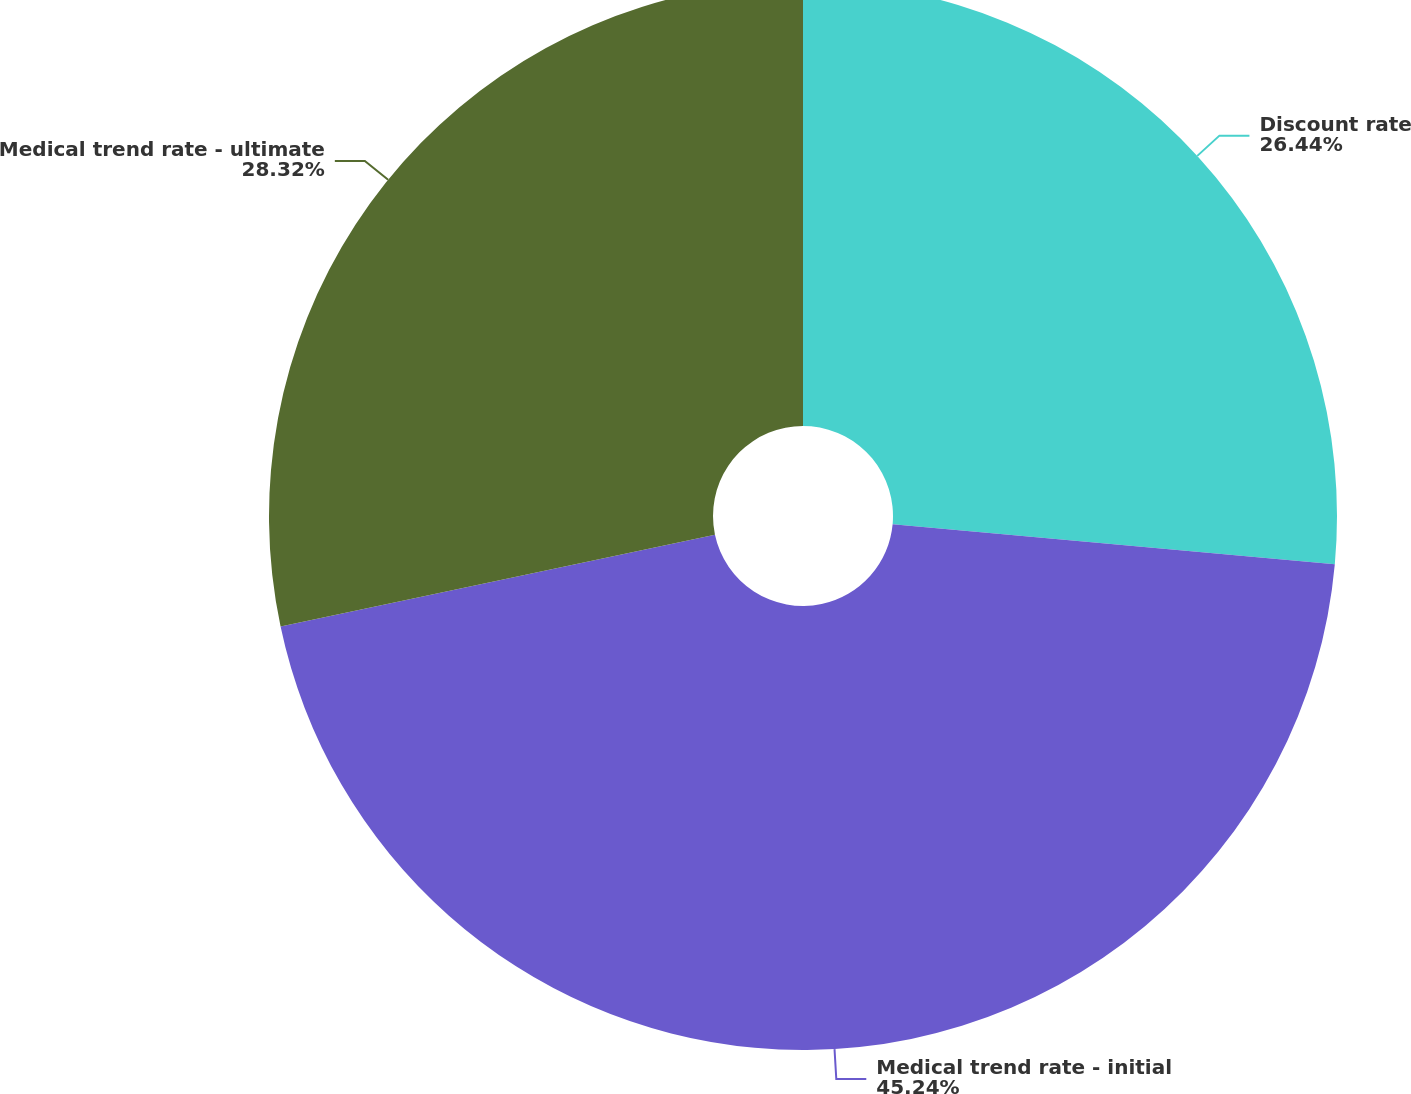Convert chart to OTSL. <chart><loc_0><loc_0><loc_500><loc_500><pie_chart><fcel>Discount rate<fcel>Medical trend rate - initial<fcel>Medical trend rate - ultimate<nl><fcel>26.44%<fcel>45.24%<fcel>28.32%<nl></chart> 